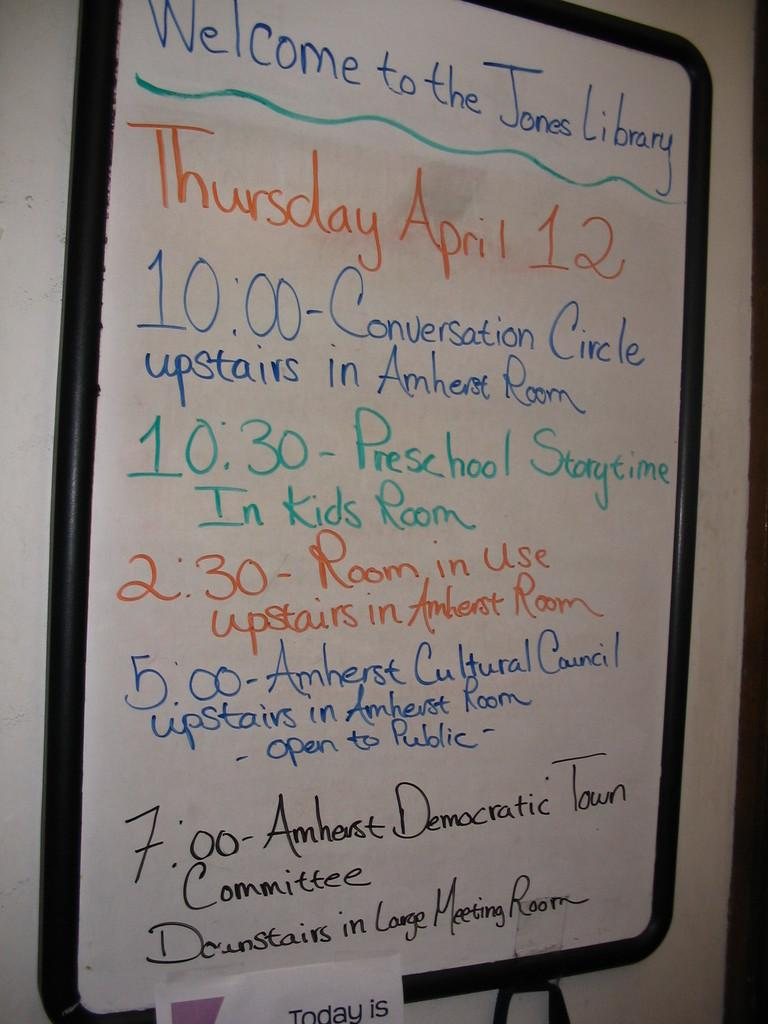<image>
Create a compact narrative representing the image presented. A whiteboard sign welcoming people to the Jones Library with a list of events. 